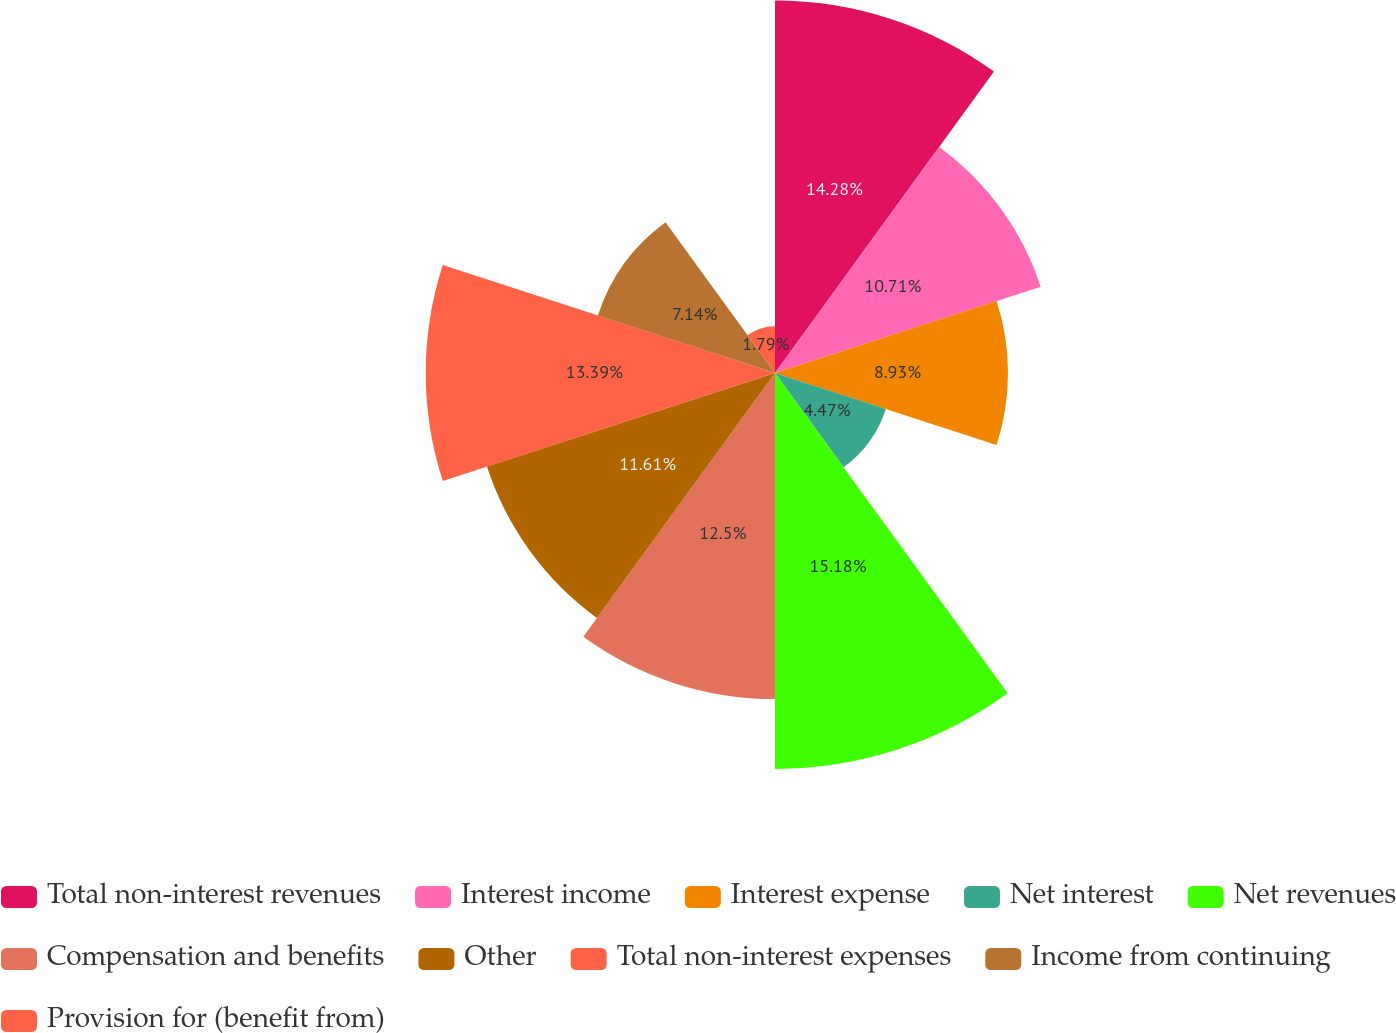<chart> <loc_0><loc_0><loc_500><loc_500><pie_chart><fcel>Total non-interest revenues<fcel>Interest income<fcel>Interest expense<fcel>Net interest<fcel>Net revenues<fcel>Compensation and benefits<fcel>Other<fcel>Total non-interest expenses<fcel>Income from continuing<fcel>Provision for (benefit from)<nl><fcel>14.28%<fcel>10.71%<fcel>8.93%<fcel>4.47%<fcel>15.18%<fcel>12.5%<fcel>11.61%<fcel>13.39%<fcel>7.14%<fcel>1.79%<nl></chart> 